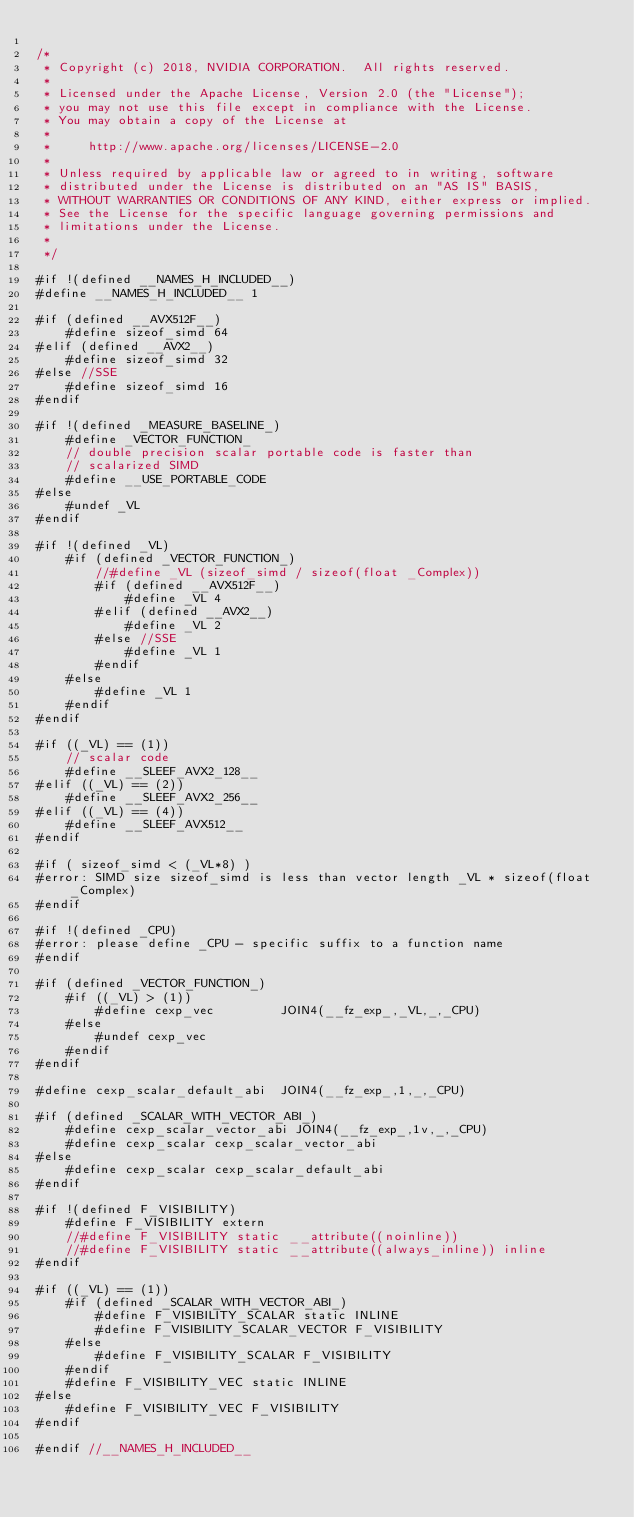<code> <loc_0><loc_0><loc_500><loc_500><_C_>
/*
 * Copyright (c) 2018, NVIDIA CORPORATION.  All rights reserved.
 *
 * Licensed under the Apache License, Version 2.0 (the "License");
 * you may not use this file except in compliance with the License.
 * You may obtain a copy of the License at
 *
 *     http://www.apache.org/licenses/LICENSE-2.0
 *
 * Unless required by applicable law or agreed to in writing, software
 * distributed under the License is distributed on an "AS IS" BASIS,
 * WITHOUT WARRANTIES OR CONDITIONS OF ANY KIND, either express or implied.
 * See the License for the specific language governing permissions and
 * limitations under the License.
 *
 */

#if !(defined __NAMES_H_INCLUDED__)
#define __NAMES_H_INCLUDED__ 1

#if (defined __AVX512F__)
    #define sizeof_simd 64
#elif (defined __AVX2__)
    #define sizeof_simd 32
#else //SSE
    #define sizeof_simd 16
#endif

#if !(defined _MEASURE_BASELINE_)
    #define _VECTOR_FUNCTION_
    // double precision scalar portable code is faster than
    // scalarized SIMD
    #define __USE_PORTABLE_CODE
#else
    #undef _VL
#endif

#if !(defined _VL)
    #if (defined _VECTOR_FUNCTION_)
        //#define _VL (sizeof_simd / sizeof(float _Complex))
        #if (defined __AVX512F__)
            #define _VL 4
        #elif (defined __AVX2__)
            #define _VL 2
        #else //SSE
            #define _VL 1
        #endif
    #else
        #define _VL 1
    #endif
#endif

#if ((_VL) == (1))
    // scalar code
    #define __SLEEF_AVX2_128__
#elif ((_VL) == (2))
    #define __SLEEF_AVX2_256__
#elif ((_VL) == (4))
    #define __SLEEF_AVX512__
#endif

#if ( sizeof_simd < (_VL*8) )
#error: SIMD size sizeof_simd is less than vector length _VL * sizeof(float _Complex)
#endif

#if !(defined _CPU)
#error: please define _CPU - specific suffix to a function name
#endif

#if (defined _VECTOR_FUNCTION_)
    #if ((_VL) > (1))
        #define cexp_vec         JOIN4(__fz_exp_,_VL,_,_CPU)
    #else
        #undef cexp_vec
    #endif
#endif

#define cexp_scalar_default_abi  JOIN4(__fz_exp_,1,_,_CPU)

#if (defined _SCALAR_WITH_VECTOR_ABI_)
    #define cexp_scalar_vector_abi JOIN4(__fz_exp_,1v,_,_CPU)
    #define cexp_scalar cexp_scalar_vector_abi
#else
    #define cexp_scalar cexp_scalar_default_abi
#endif

#if !(defined F_VISIBILITY)
    #define F_VISIBILITY extern
    //#define F_VISIBILITY static __attribute((noinline))
    //#define F_VISIBILITY static __attribute((always_inline)) inline
#endif

#if ((_VL) == (1))
    #if (defined _SCALAR_WITH_VECTOR_ABI_)
        #define F_VISIBILITY_SCALAR static INLINE
        #define F_VISIBILITY_SCALAR_VECTOR F_VISIBILITY
    #else
        #define F_VISIBILITY_SCALAR F_VISIBILITY
    #endif
    #define F_VISIBILITY_VEC static INLINE
#else
    #define F_VISIBILITY_VEC F_VISIBILITY
#endif

#endif //__NAMES_H_INCLUDED__
</code> 